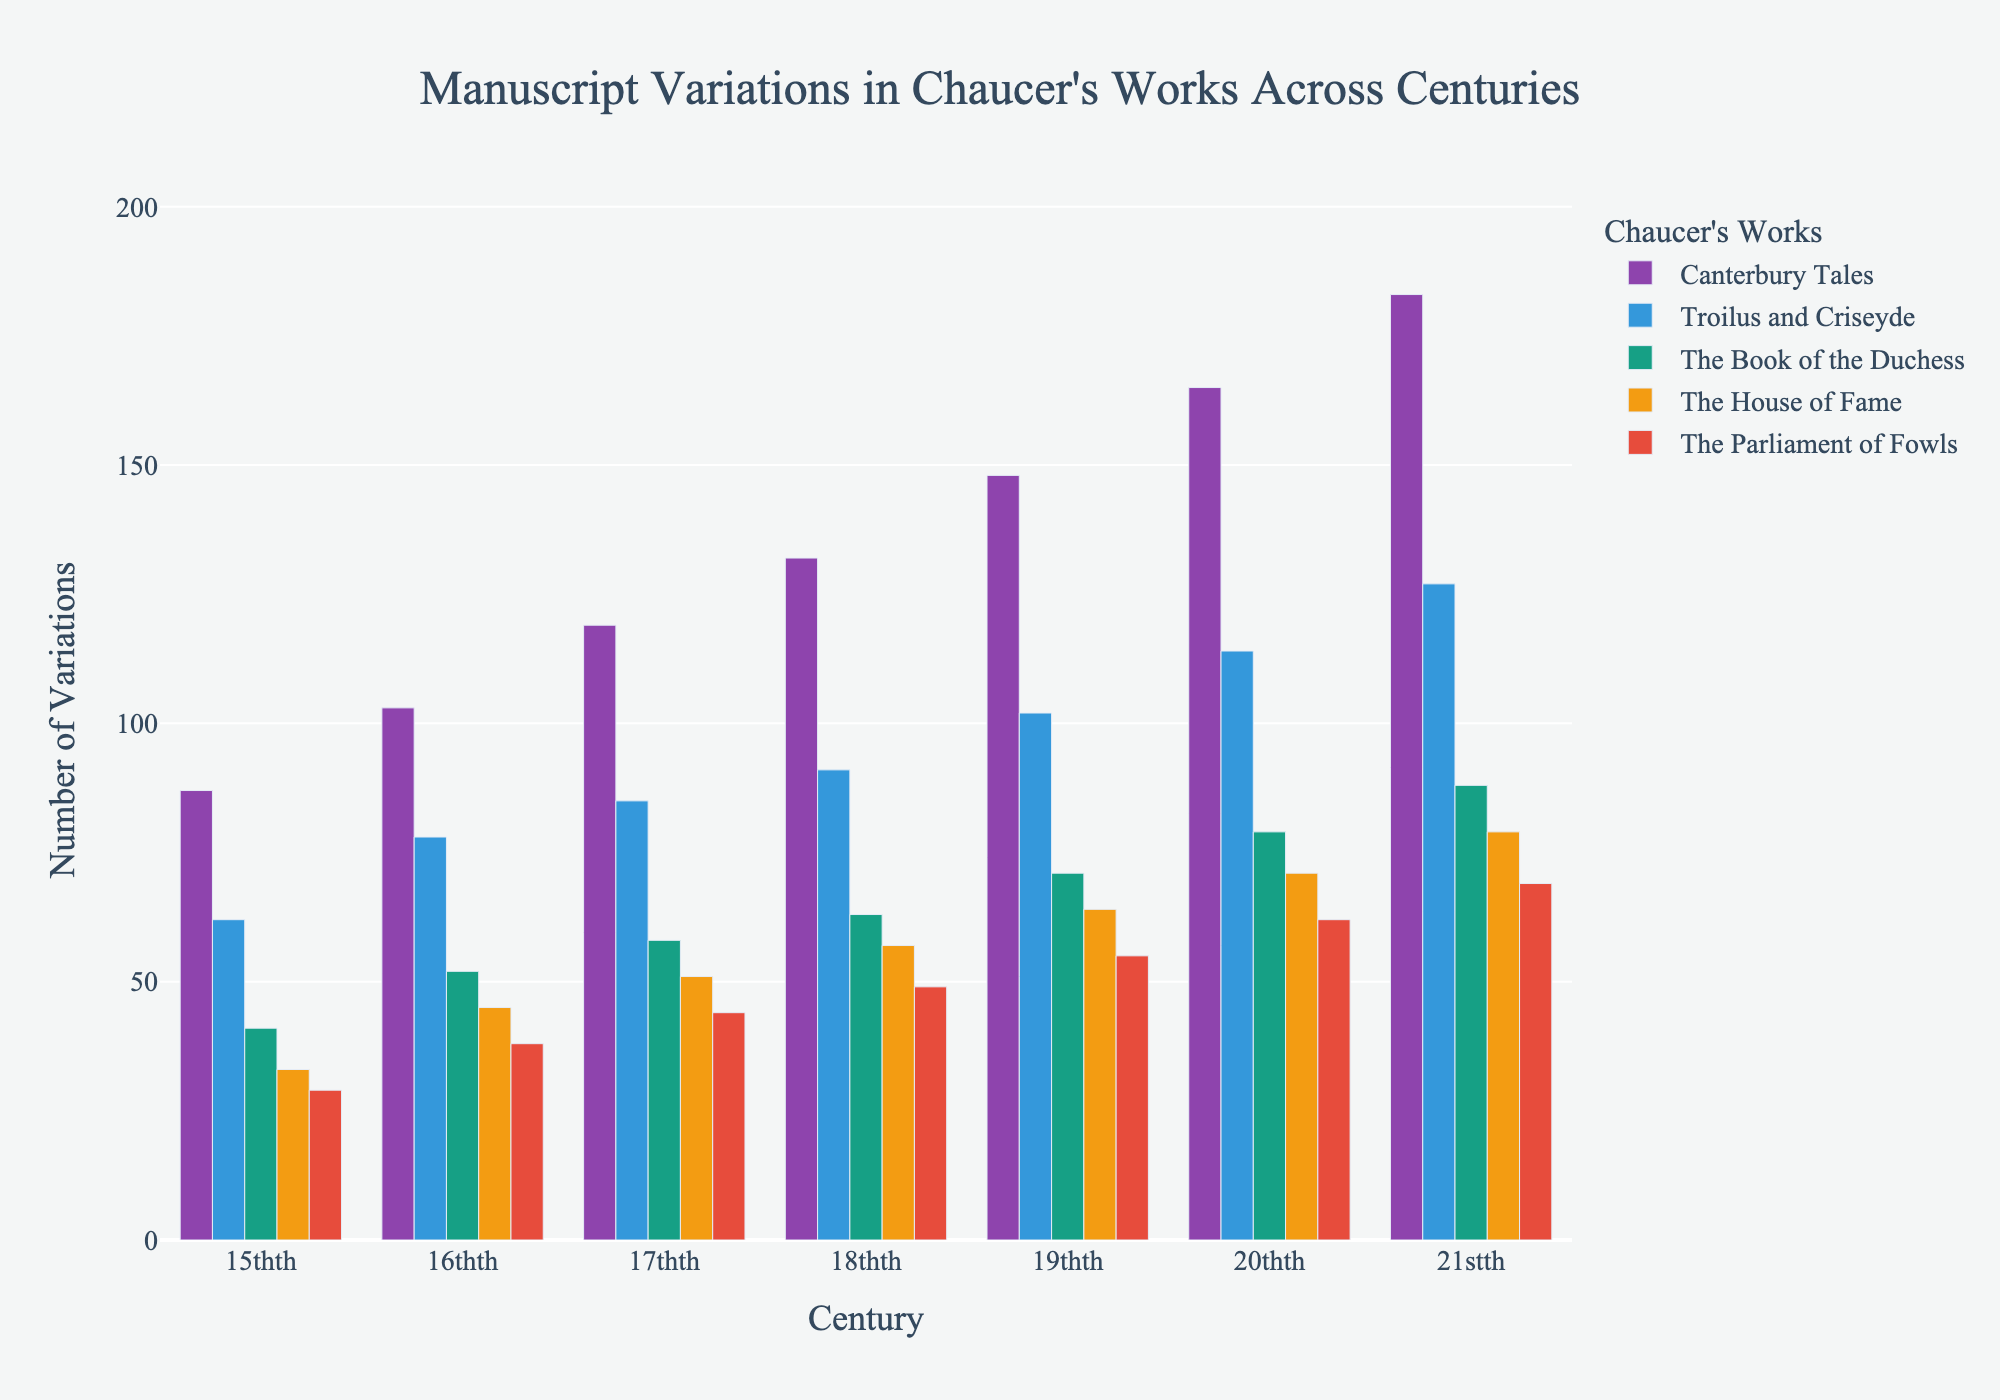Which century shows the highest number of variations for "The Canterbury Tales"? In the 21st century, "The Canterbury Tales" has the highest number of variations at 183. This is evident as the bar corresponding to the 21st century is the tallest for "The Canterbury Tales".
Answer: 21st century How does the number of variations for "Troilus and Criseyde" in the 20th century compare to the 15th century? The bar for "Troilus and Criseyde" in the 20th century shows 114 variations, while the 15th century shows 62 variations. Comparing these, the 20th-century bar is significantly taller, indicating nearly double the variations.
Answer: 20th century has almost twice the variations of the 15th century What is the total number of variations for "The House of Fame" across all centuries? Summing the variations for "The House of Fame" across the centuries: 33 (15th) + 45 (16th) + 51 (17th) + 57 (18th) + 64 (19th) + 71 (20th) + 79 (21st) = 400.
Answer: 400 Which work shows the smallest increase in variations from the 19th to the 21st century? Calculate the increase for each work: "Canterbury Tales" (183-148=35), "Troilus and Criseyde" (127-102=25), "The Book of the Duchess" (88-71=17), "The House of Fame" (79-64=15), and "The Parliament of Fowls" (69-55=14). "The Parliament of Fowls" has the smallest increase.
Answer: The Parliament of Fowls What is the average number of variations for "The Book of the Duchess" across all centuries? Sum the variations for "The Book of the Duchess" over all centuries: 41 + 52 + 58 + 63 + 71 + 79 + 88 = 452. The average is 452 divided by 7 (the number of centuries), which equals approximately 64.57.
Answer: Around 64.57 Which century shows the greatest difference in the number of variations between "The Parliament of Fowls" and "The Canterbury Tales"? Calculate the difference for each century: 15th (87-29=58), 16th (103-38=65), 17th (119-44=75), 18th (132-49=83), 19th (148-55=93), 20th (165-62=103), 21st (183-69=114). The 21st century has the greatest difference at 114.
Answer: 21st century How does the number of variations for "The Book of the Duchess" in the 17th century compare to "The House of Fame" in the 18th century? The 17th century "The Book of the Duchess" shows 58 variations compared to the 18th century "The House of Fame" with 57 variations. The bars indicate that "The Book of the Duchess" has just one more variation than "The House of Fame".
Answer: 58 vs 57 What is the overall trend in the number of variations for Chaucer's works from the 15th to the 21st century? Visually, all bars show an upward trend, indicating an increase in the number of variations for all works from the 15th to the 21st century. The trend is consistent across all works.
Answer: Increasing Which work has the most consistent number of variations over the centuries? By examining the fluctuations in bar heights, "The House of Fame" shows relatively minor changes from century to century compared to the other works. This consistency is seen in the relatively even spacing of its bars.
Answer: The House of Fame 